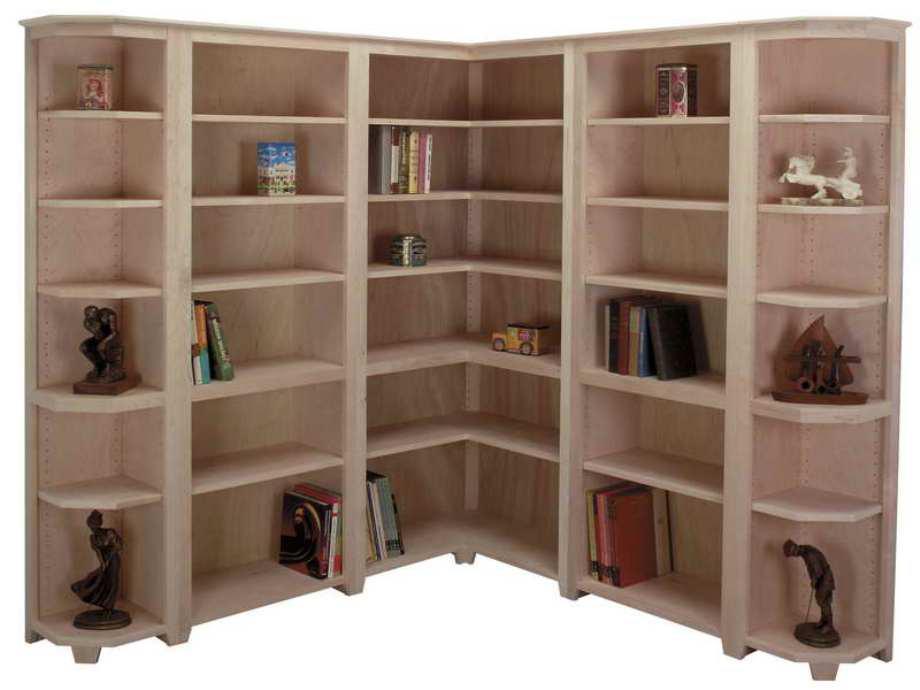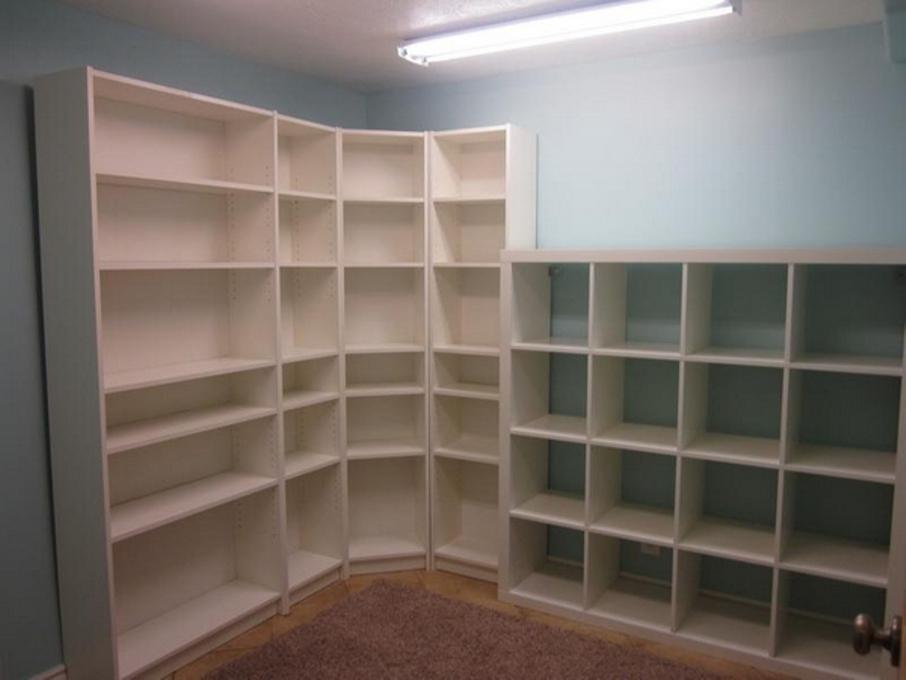The first image is the image on the left, the second image is the image on the right. Given the left and right images, does the statement "One image shows a completely empty white shelf while the other shows a shelf with contents, and all shelves are designed to fit in a corner." hold true? Answer yes or no. Yes. 